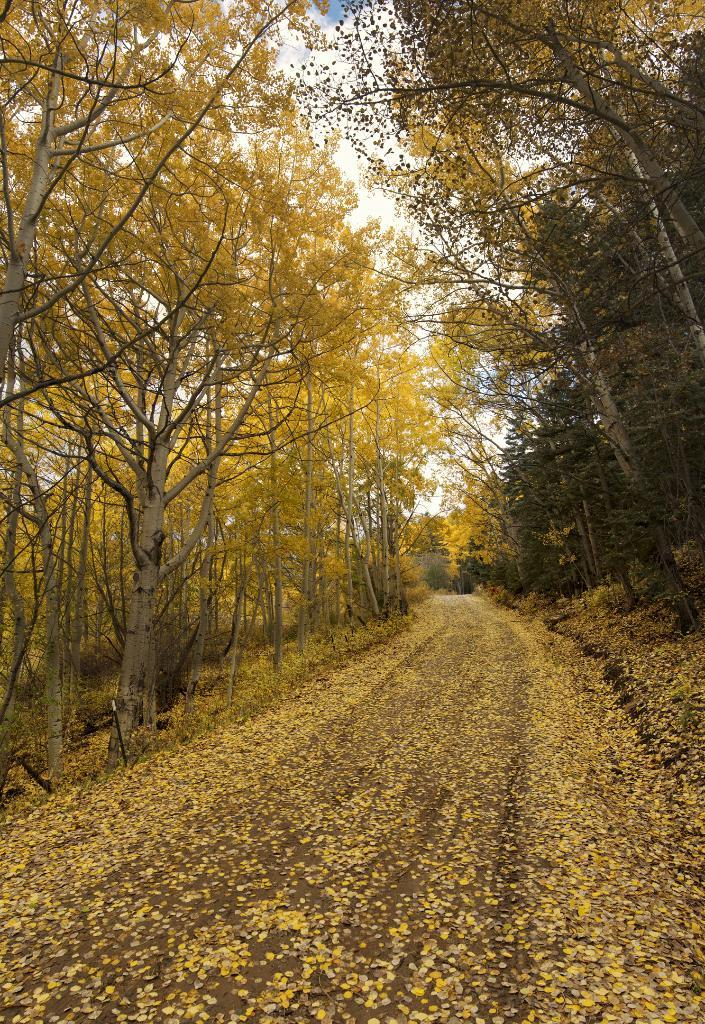What is the main feature of the image? The image contains a road. How is the road different from a typical road? The road is covered with flowers. What can be seen on both sides of the road? There are trees on both sides of the road. What is visible in the background of the image? The sky is visible in the image, and there are clouds in the sky. How many goldfish can be seen swimming in the road in the image? There are no goldfish present in the image; the road is covered with flowers. What type of addition problem can be solved using the numbers on the trees in the image? There are no numbers visible on the trees in the image, so it is not possible to solve an addition problem based on the information provided. 